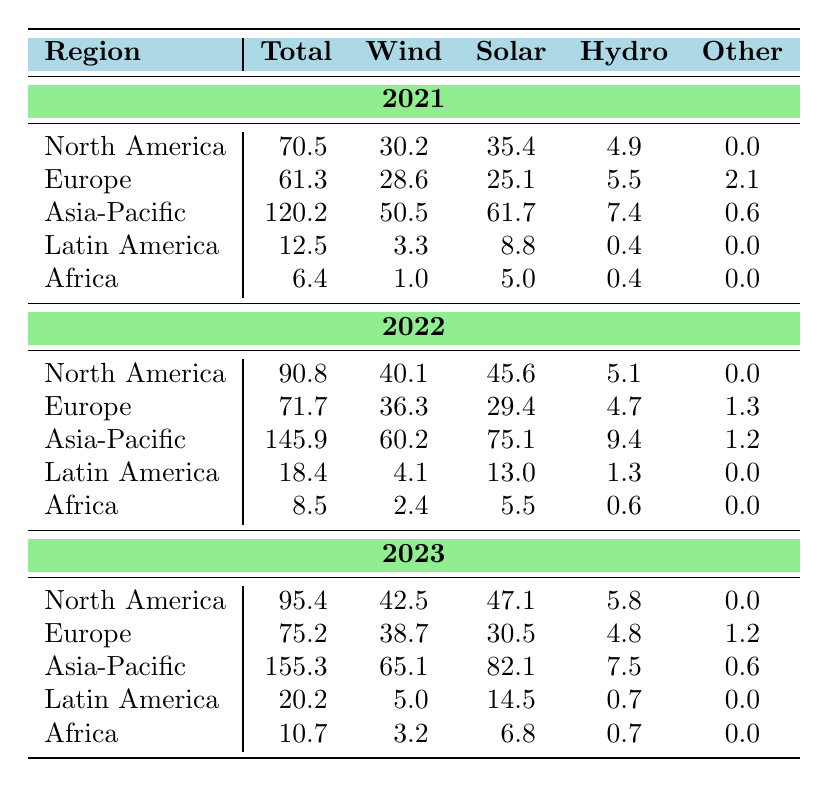What was the total investment in renewable energy in Asia-Pacific in 2022? The table shows that the total investment in Asia-Pacific in 2022 is listed as 145.9.
Answer: 145.9 Which region had the highest investment in solar energy in 2023? In 2023, the table indicates that Asia-Pacific had the highest investment in solar energy, with an amount of 82.1.
Answer: Asia-Pacific What is the difference in total investment between North America in 2021 and 2022? From the table, North America's total investment in 2021 is 70.5 and in 2022 is 90.8. The difference is calculated as 90.8 - 70.5 = 20.3.
Answer: 20.3 Does Europe have more investment in wind energy than Africa in 2022? In the table, Europe's wind energy investment in 2022 is 36.3, while Africa's is 2.4. Since 36.3 is greater than 2.4, the statement is true.
Answer: Yes What is the total investment in renewable energy for all regions combined in 2023? To find this, we sum the total investments for all regions in 2023: 95.4 (North America) + 75.2 (Europe) + 155.3 (Asia-Pacific) + 20.2 (Latin America) + 10.7 (Africa) = 357.8.
Answer: 357.8 In which year did Latin America see the largest increase in total investment compared to the previous year? By examining the total investments, Latin America's investments were 12.5 in 2021, 18.4 in 2022, and 20.2 in 2023. The increase from 2021 to 2022 is 5.9, and from 2022 to 2023, it is 1.8. The larger increase is from 2021 to 2022.
Answer: 2022 What is the average investment in hydro energy across all regions in 2021? For 2021, the hydro investments are: 4.9 (North America), 5.5 (Europe), 7.4 (Asia-Pacific), 0.4 (Latin America), and 0.4 (Africa). Summing these gives 18.6. Dividing by the 5 regions gives an average of 18.6 / 5 = 3.72.
Answer: 3.72 Has the total investment in Africa increased every year from 2021 to 2023? The total investments show 6.4 in 2021, 8.5 in 2022, and 10.7 in 2023. Since each subsequent total is greater than the previous one, the statement is true.
Answer: Yes What is the percentage increase in total investment for Asia-Pacific from 2021 to 2022? The total investment for Asia-Pacific in 2021 is 120.2 and in 2022 is 145.9. The increase is 145.9 - 120.2 = 25.7. The percentage increase is (25.7 / 120.2) * 100 = 21.39%.
Answer: 21.39% 